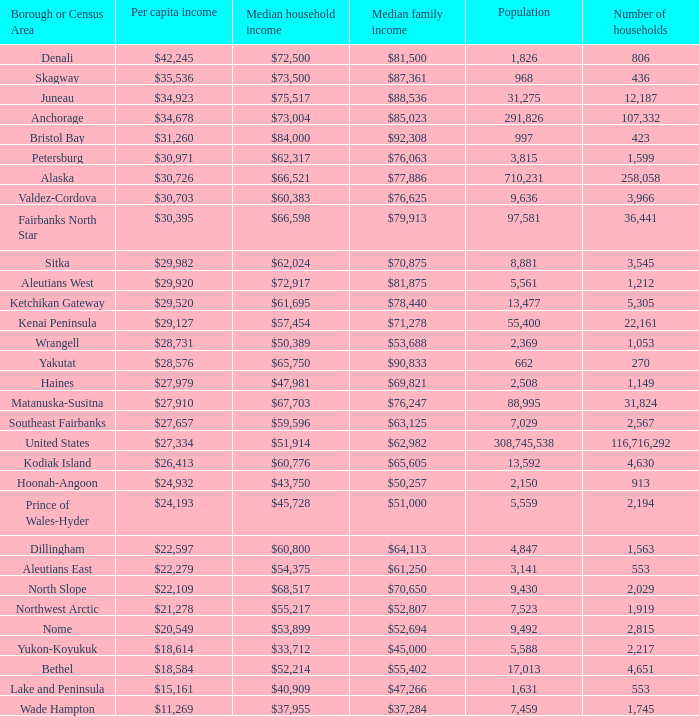Which borough or census area has a $59,596 median household income? Southeast Fairbanks. 